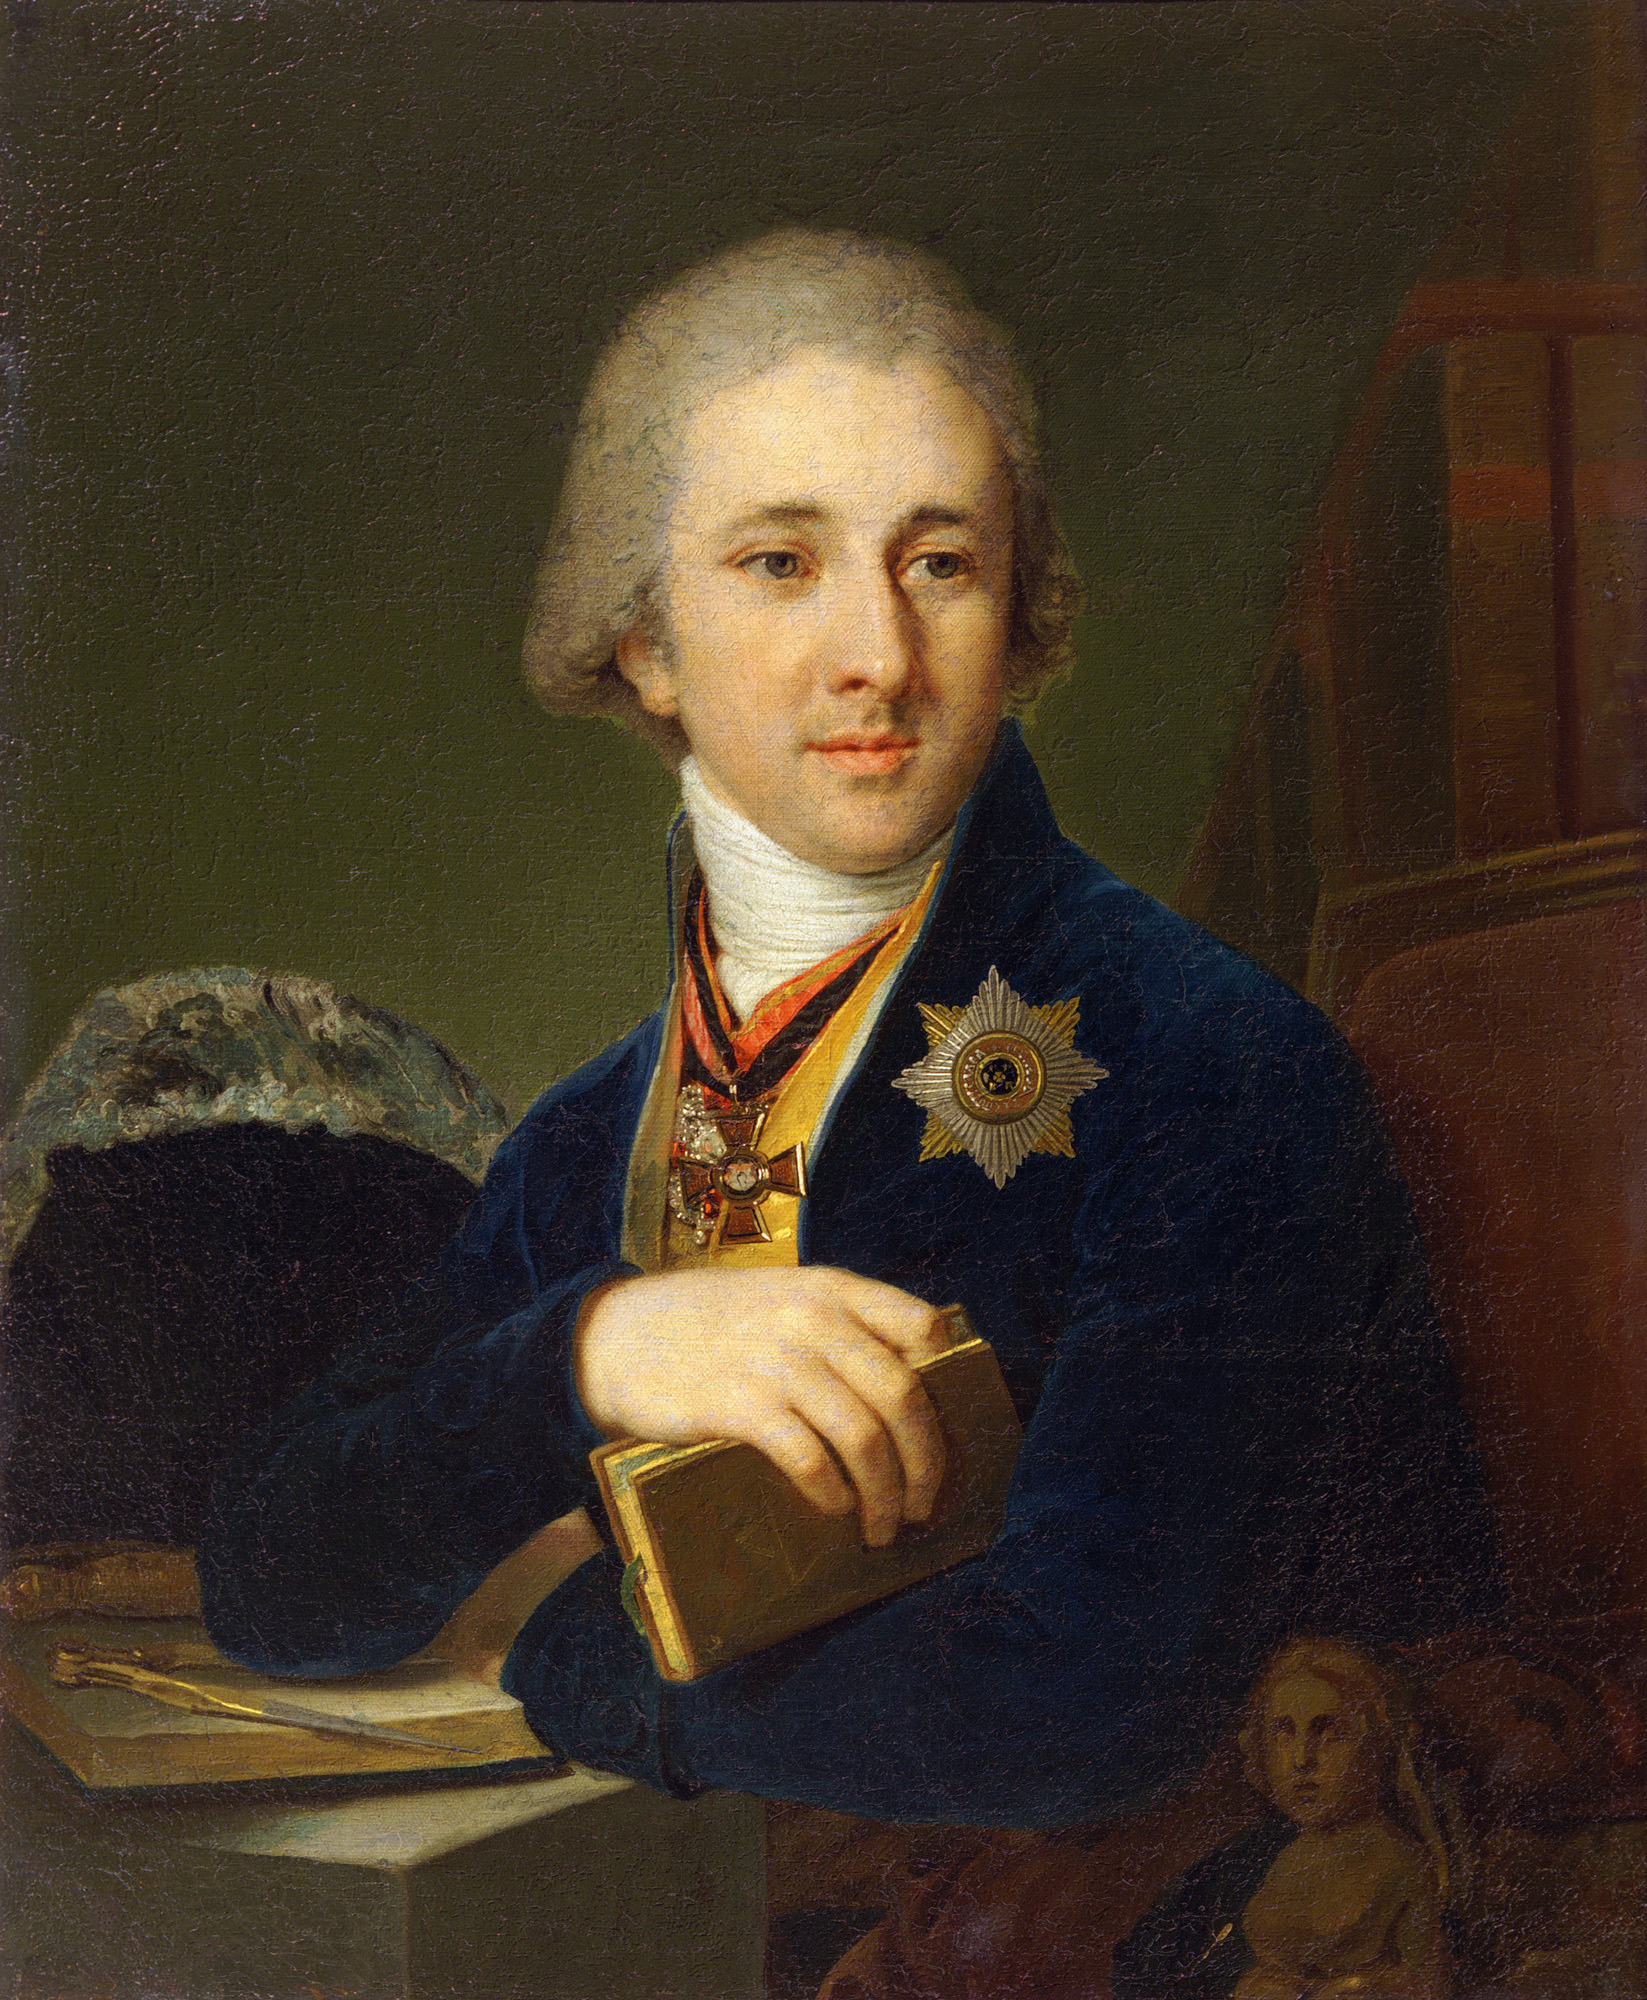What is this photo about'?
 The image portrays a man of distinction, dressed in a blue coat adorned with a medal on his chest, signifying some form of honor or achievement. His white wig, a common fashion in certain historical periods, adds an air of sophistication and status. In his hand, he holds a book, suggesting a scholarly or intellectual disposition. The backdrop is a rich, dark green, against which hangs a painting of a woman, adding a layer of depth and intrigue to the scene. The art style is realistic, capturing the minute details of the man's attire and features with precision. This style, combined with the subject matter, places the work firmly within the genre of portraiture. 